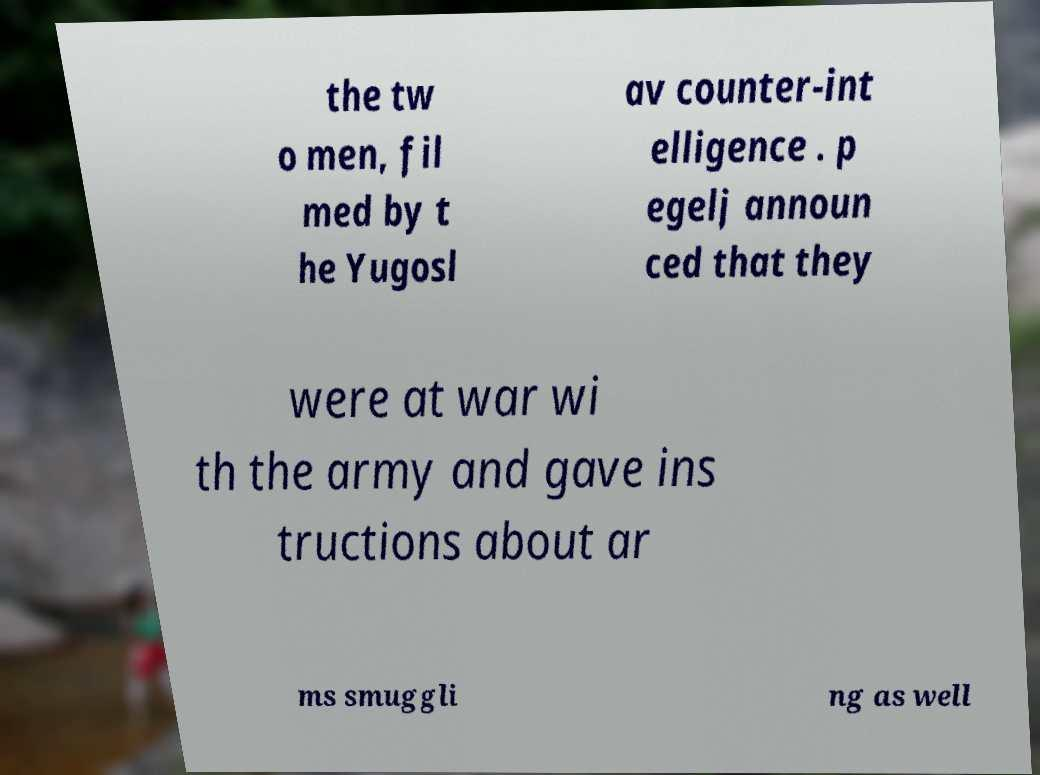For documentation purposes, I need the text within this image transcribed. Could you provide that? the tw o men, fil med by t he Yugosl av counter-int elligence . p egelj announ ced that they were at war wi th the army and gave ins tructions about ar ms smuggli ng as well 